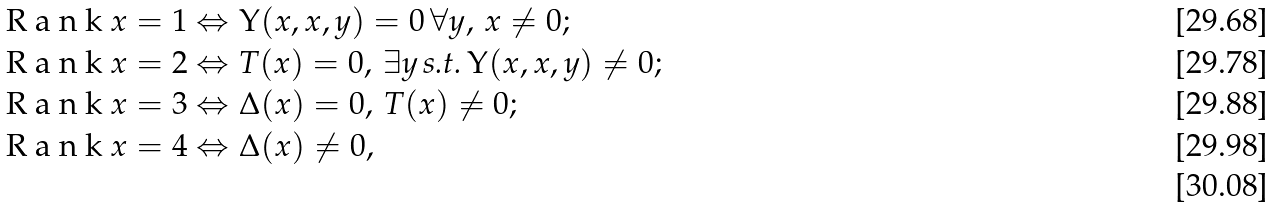<formula> <loc_0><loc_0><loc_500><loc_500>\emph { R a n k } x = 1 & \Leftrightarrow \Upsilon ( x , x , y ) = 0 \, \forall y , \, x \not = 0 ; \\ \emph { R a n k } x = 2 & \Leftrightarrow T ( x ) = 0 , \, \exists y \, \text {s.t.} \, \Upsilon ( x , x , y ) \not = 0 ; \\ \emph { R a n k } x = 3 & \Leftrightarrow \Delta ( x ) = 0 , \, T ( x ) \not = 0 ; \\ \emph { R a n k } x = 4 & \Leftrightarrow \Delta ( x ) \not = 0 , \\</formula> 